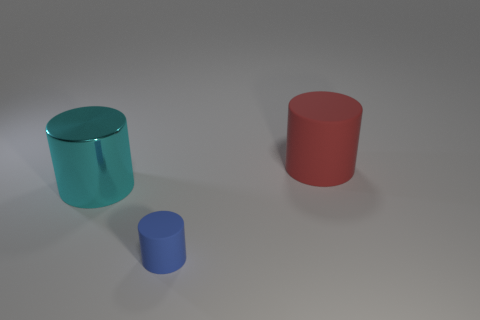Add 1 big objects. How many objects exist? 4 Subtract all metallic cylinders. How many cylinders are left? 2 Subtract 0 gray cylinders. How many objects are left? 3 Subtract 1 cylinders. How many cylinders are left? 2 Subtract all red cylinders. Subtract all blue blocks. How many cylinders are left? 2 Subtract all purple cubes. How many brown cylinders are left? 0 Subtract all large cyan cylinders. Subtract all cyan objects. How many objects are left? 1 Add 3 large cylinders. How many large cylinders are left? 5 Add 1 tiny blue matte things. How many tiny blue matte things exist? 2 Subtract all red cylinders. How many cylinders are left? 2 